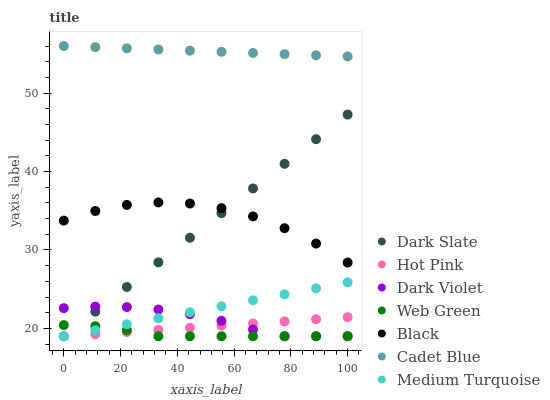Does Web Green have the minimum area under the curve?
Answer yes or no. Yes. Does Cadet Blue have the maximum area under the curve?
Answer yes or no. Yes. Does Hot Pink have the minimum area under the curve?
Answer yes or no. No. Does Hot Pink have the maximum area under the curve?
Answer yes or no. No. Is Hot Pink the smoothest?
Answer yes or no. Yes. Is Black the roughest?
Answer yes or no. Yes. Is Web Green the smoothest?
Answer yes or no. No. Is Web Green the roughest?
Answer yes or no. No. Does Hot Pink have the lowest value?
Answer yes or no. Yes. Does Black have the lowest value?
Answer yes or no. No. Does Cadet Blue have the highest value?
Answer yes or no. Yes. Does Hot Pink have the highest value?
Answer yes or no. No. Is Dark Slate less than Cadet Blue?
Answer yes or no. Yes. Is Cadet Blue greater than Black?
Answer yes or no. Yes. Does Hot Pink intersect Dark Violet?
Answer yes or no. Yes. Is Hot Pink less than Dark Violet?
Answer yes or no. No. Is Hot Pink greater than Dark Violet?
Answer yes or no. No. Does Dark Slate intersect Cadet Blue?
Answer yes or no. No. 